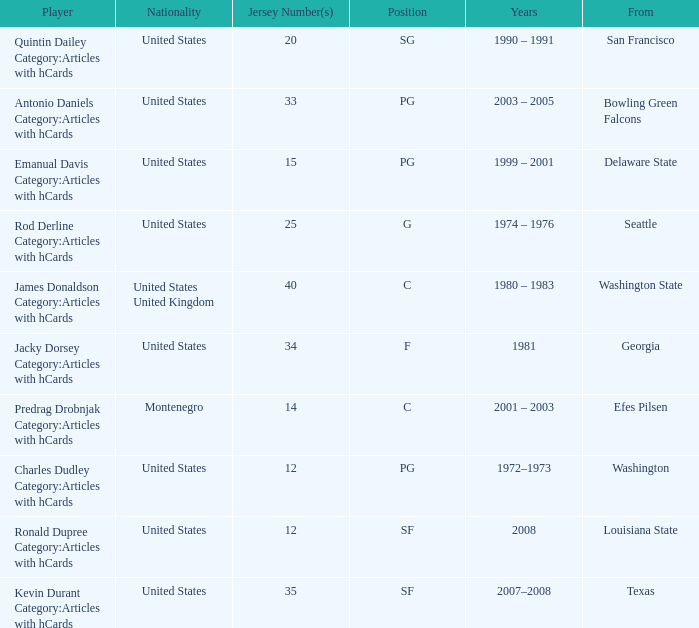What school was the competitor with the 34-numbered jersey associated with? Georgia. 